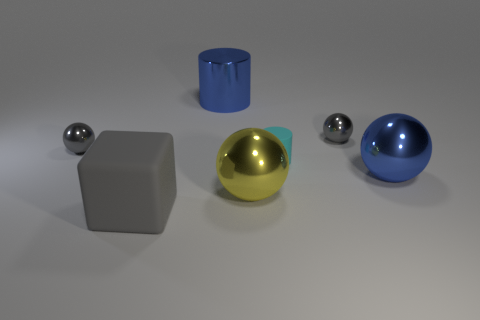Subtract all yellow balls. How many balls are left? 3 Add 1 large metallic objects. How many objects exist? 8 Subtract all green cylinders. How many gray spheres are left? 2 Subtract all blue balls. How many balls are left? 3 Subtract 2 spheres. How many spheres are left? 2 Subtract all blocks. How many objects are left? 6 Subtract all big brown shiny cylinders. Subtract all blocks. How many objects are left? 6 Add 2 gray spheres. How many gray spheres are left? 4 Add 2 tiny gray balls. How many tiny gray balls exist? 4 Subtract 0 red spheres. How many objects are left? 7 